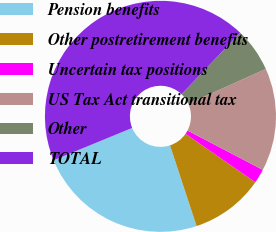Convert chart to OTSL. <chart><loc_0><loc_0><loc_500><loc_500><pie_chart><fcel>Pension benefits<fcel>Other postretirement benefits<fcel>Uncertain tax positions<fcel>US Tax Act transitional tax<fcel>Other<fcel>TOTAL<nl><fcel>23.86%<fcel>10.27%<fcel>2.0%<fcel>14.4%<fcel>6.14%<fcel>43.33%<nl></chart> 